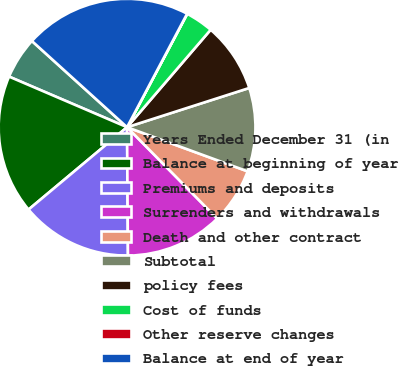Convert chart to OTSL. <chart><loc_0><loc_0><loc_500><loc_500><pie_chart><fcel>Years Ended December 31 (in<fcel>Balance at beginning of year<fcel>Premiums and deposits<fcel>Surrenders and withdrawals<fcel>Death and other contract<fcel>Subtotal<fcel>policy fees<fcel>Cost of funds<fcel>Other reserve changes<fcel>Balance at end of year<nl><fcel>5.27%<fcel>17.53%<fcel>14.03%<fcel>12.28%<fcel>7.02%<fcel>10.53%<fcel>8.77%<fcel>3.52%<fcel>0.02%<fcel>21.03%<nl></chart> 